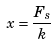<formula> <loc_0><loc_0><loc_500><loc_500>x = { \frac { F _ { s } } { k } }</formula> 